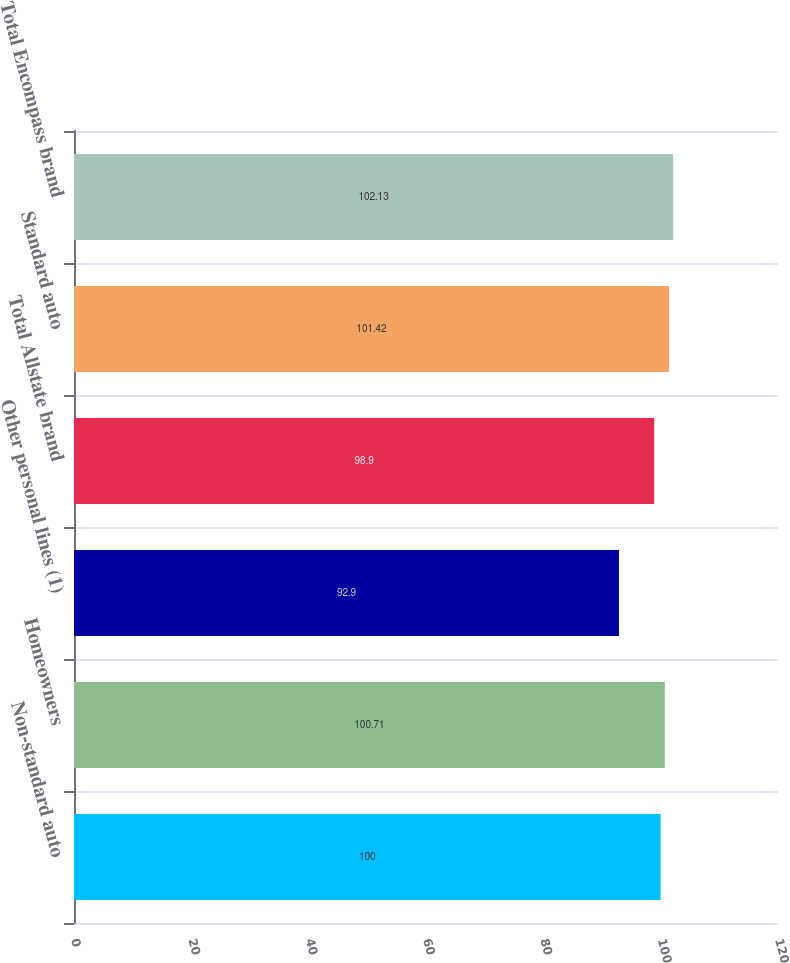Convert chart to OTSL. <chart><loc_0><loc_0><loc_500><loc_500><bar_chart><fcel>Non-standard auto<fcel>Homeowners<fcel>Other personal lines (1)<fcel>Total Allstate brand<fcel>Standard auto<fcel>Total Encompass brand<nl><fcel>100<fcel>100.71<fcel>92.9<fcel>98.9<fcel>101.42<fcel>102.13<nl></chart> 